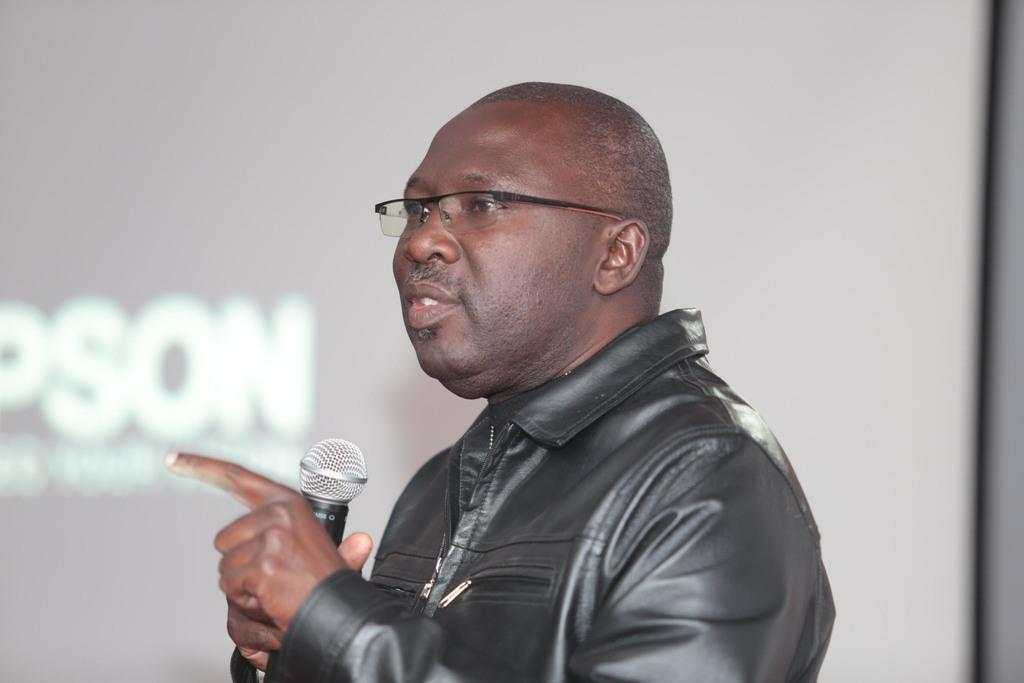Who is the person in the image? There is a man in the image. What is the man wearing? The man is wearing a black jacket. What is the man doing in the image? The man is speaking on a microphone. What can be seen in the background of the image? There is a screen in the background of the image. What is displayed on the screen? There is text on the screen. Is the man in the image expressing his hate for machines while sleeping? There is no indication in the image that the man is sleeping or expressing any emotions towards machines. 